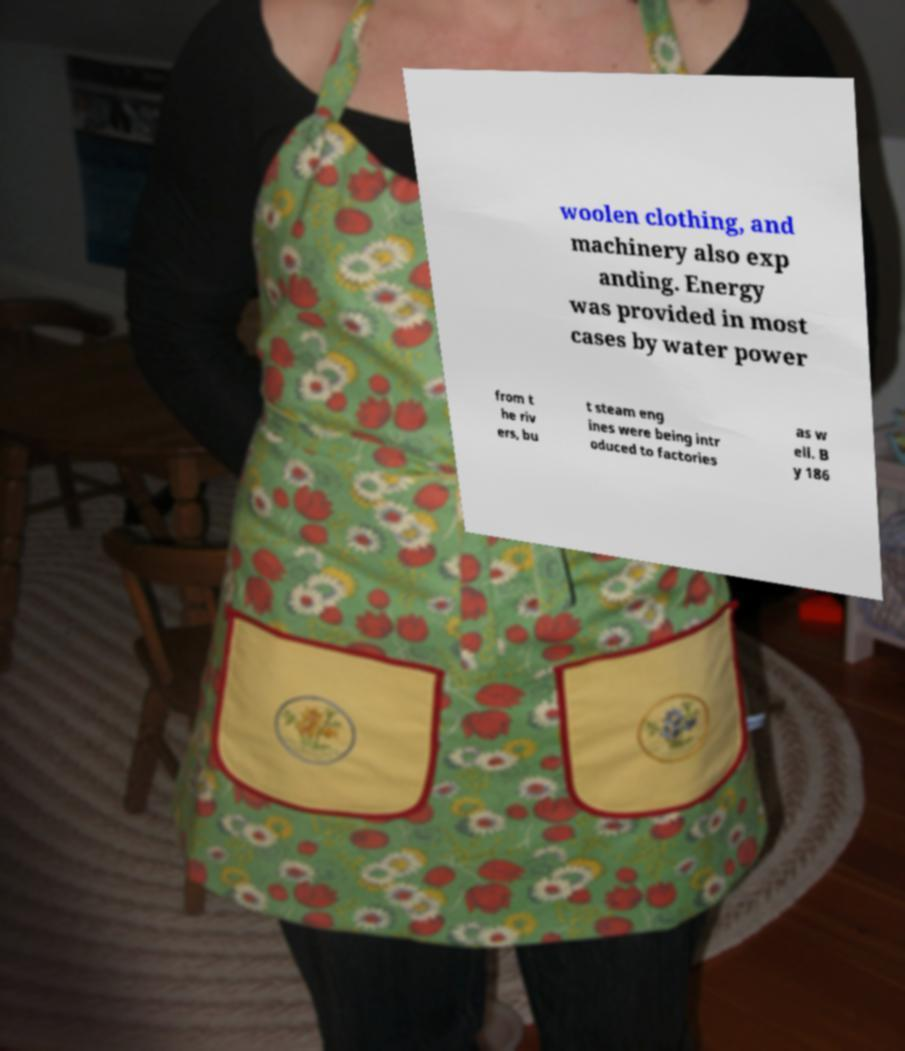Please read and relay the text visible in this image. What does it say? woolen clothing, and machinery also exp anding. Energy was provided in most cases by water power from t he riv ers, bu t steam eng ines were being intr oduced to factories as w ell. B y 186 